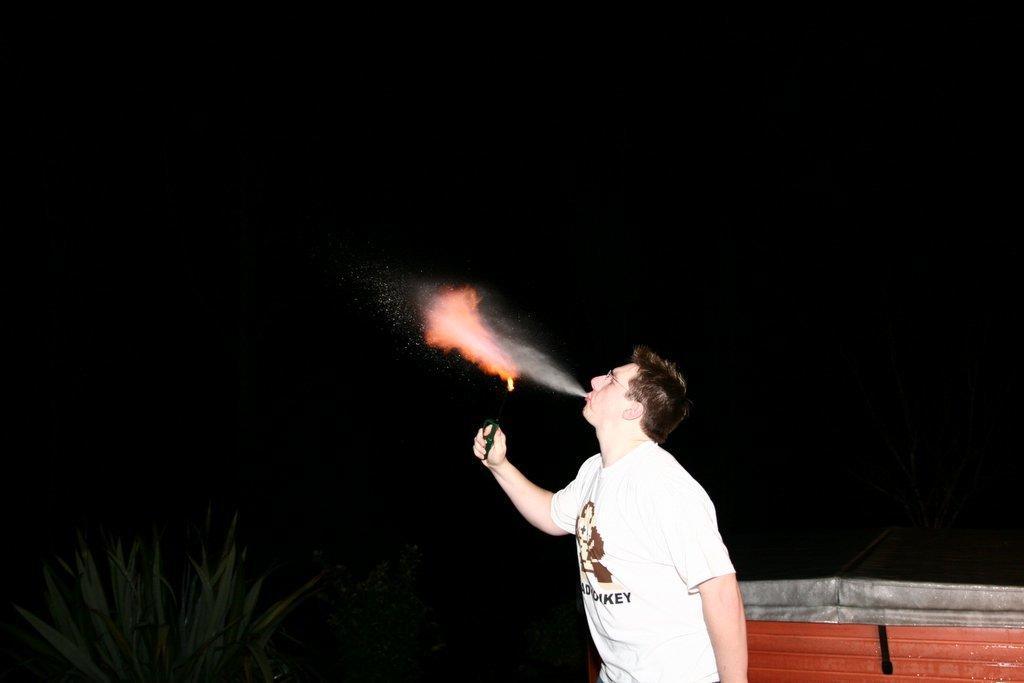In one or two sentences, can you explain what this image depicts? In this image we can see a man wearing white T-shirt is blowing something and holding some object. In the background, we can see the wall, plants and the background of the image is dark. 